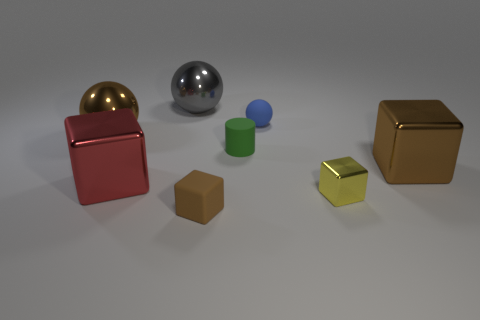Add 1 large red metal things. How many objects exist? 9 Subtract all cylinders. How many objects are left? 7 Subtract all large blocks. Subtract all metal things. How many objects are left? 1 Add 6 tiny cubes. How many tiny cubes are left? 8 Add 4 big brown metallic balls. How many big brown metallic balls exist? 5 Subtract 0 purple cylinders. How many objects are left? 8 